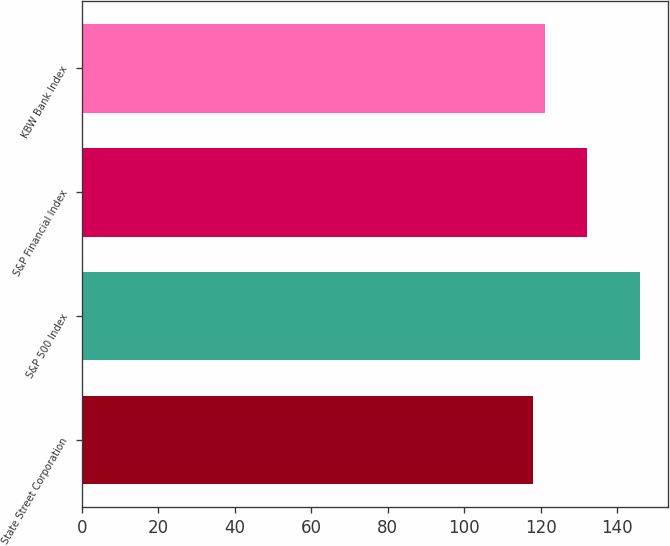Convert chart to OTSL. <chart><loc_0><loc_0><loc_500><loc_500><bar_chart><fcel>State Street Corporation<fcel>S&P 500 Index<fcel>S&P Financial Index<fcel>KBW Bank Index<nl><fcel>118<fcel>146<fcel>132<fcel>121<nl></chart> 